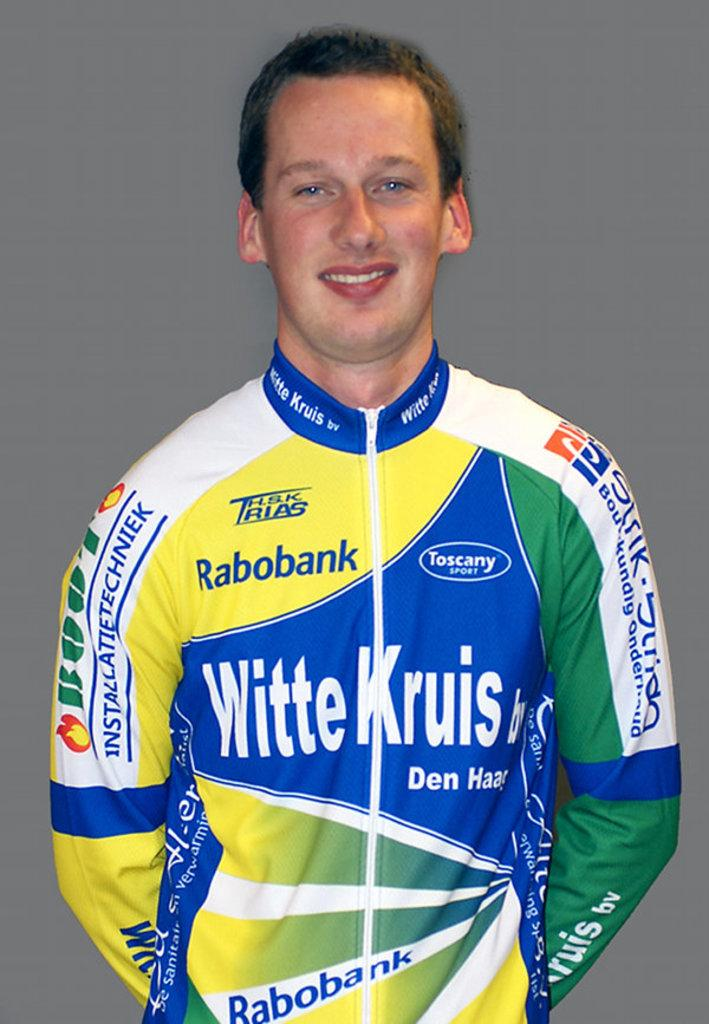<image>
Share a concise interpretation of the image provided. smiling man in racing suit with sponsors such as rabobank, witte kruis, and toscany sport 